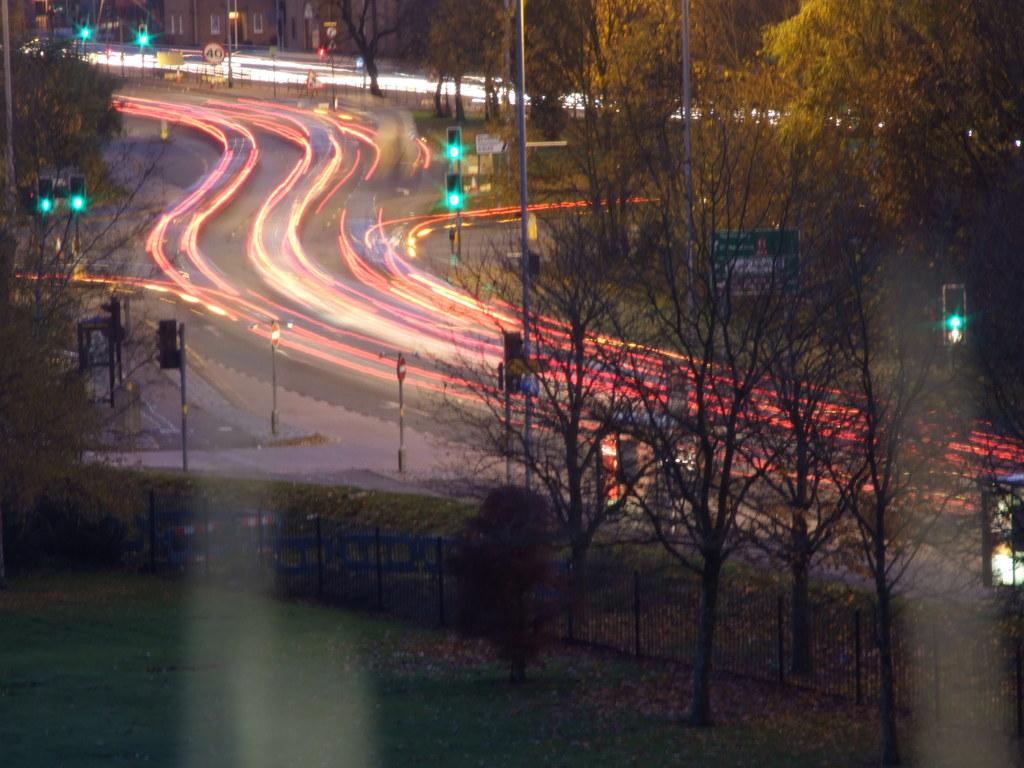What is happening on the road in the image? There are vehicles moving quickly on the road. What can be seen near the road? Trees and grass are visible near the road. What type of soda is being served at the learning edge in the image? There is no mention of learning or soda in the image; it only shows vehicles moving quickly on the road with trees and grass nearby. 